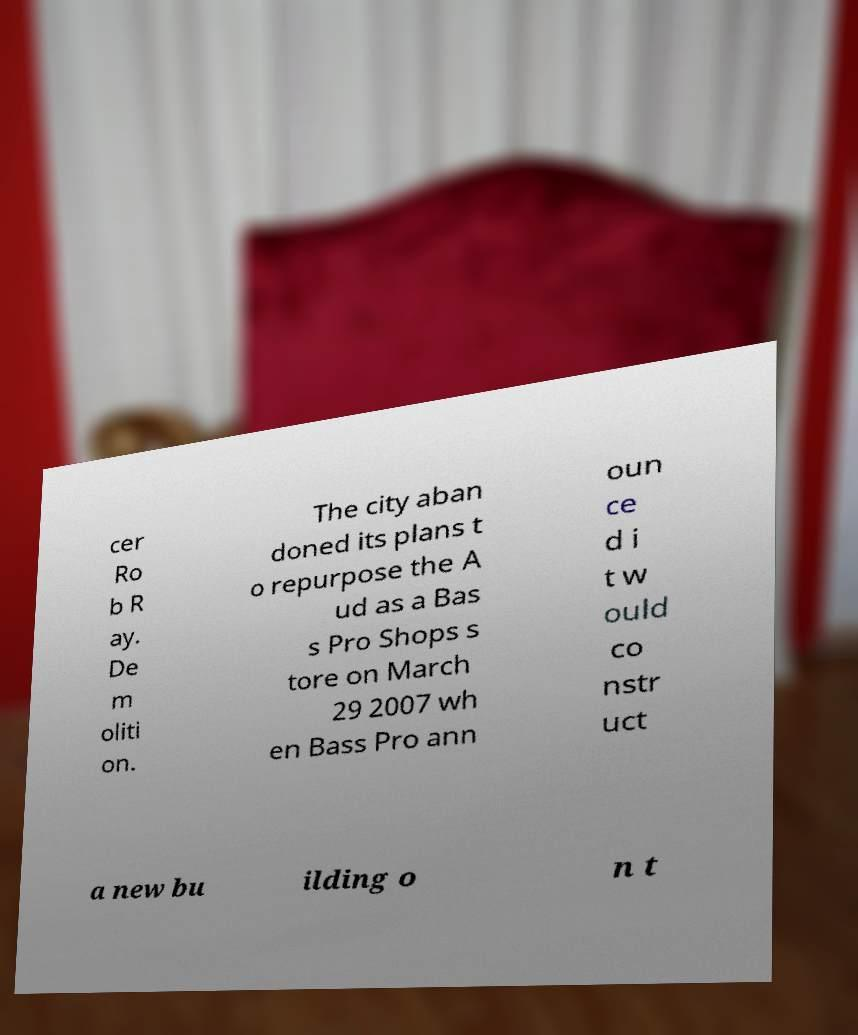There's text embedded in this image that I need extracted. Can you transcribe it verbatim? cer Ro b R ay. De m oliti on. The city aban doned its plans t o repurpose the A ud as a Bas s Pro Shops s tore on March 29 2007 wh en Bass Pro ann oun ce d i t w ould co nstr uct a new bu ilding o n t 